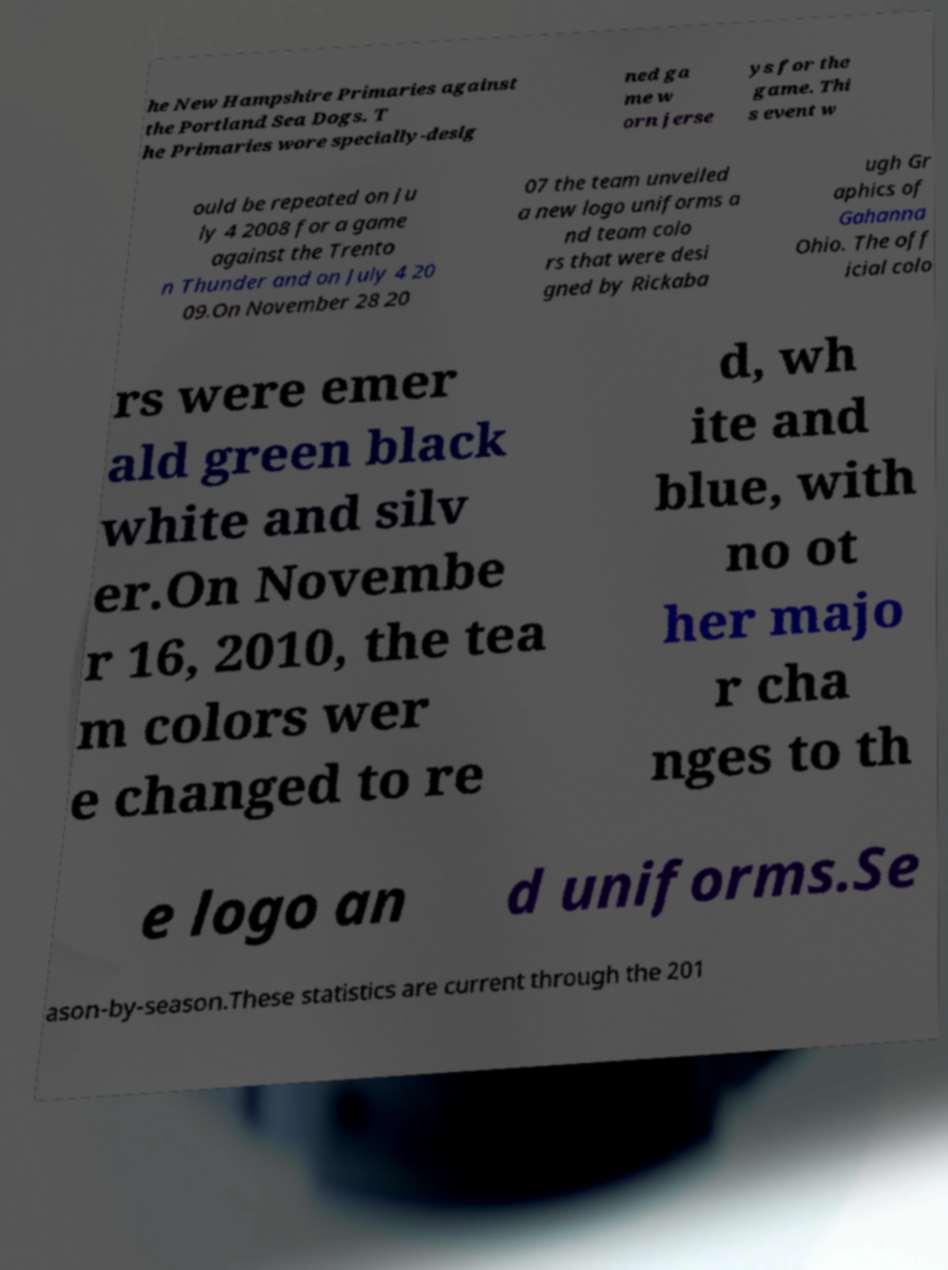What messages or text are displayed in this image? I need them in a readable, typed format. he New Hampshire Primaries against the Portland Sea Dogs. T he Primaries wore specially-desig ned ga me w orn jerse ys for the game. Thi s event w ould be repeated on Ju ly 4 2008 for a game against the Trento n Thunder and on July 4 20 09.On November 28 20 07 the team unveiled a new logo uniforms a nd team colo rs that were desi gned by Rickaba ugh Gr aphics of Gahanna Ohio. The off icial colo rs were emer ald green black white and silv er.On Novembe r 16, 2010, the tea m colors wer e changed to re d, wh ite and blue, with no ot her majo r cha nges to th e logo an d uniforms.Se ason-by-season.These statistics are current through the 201 